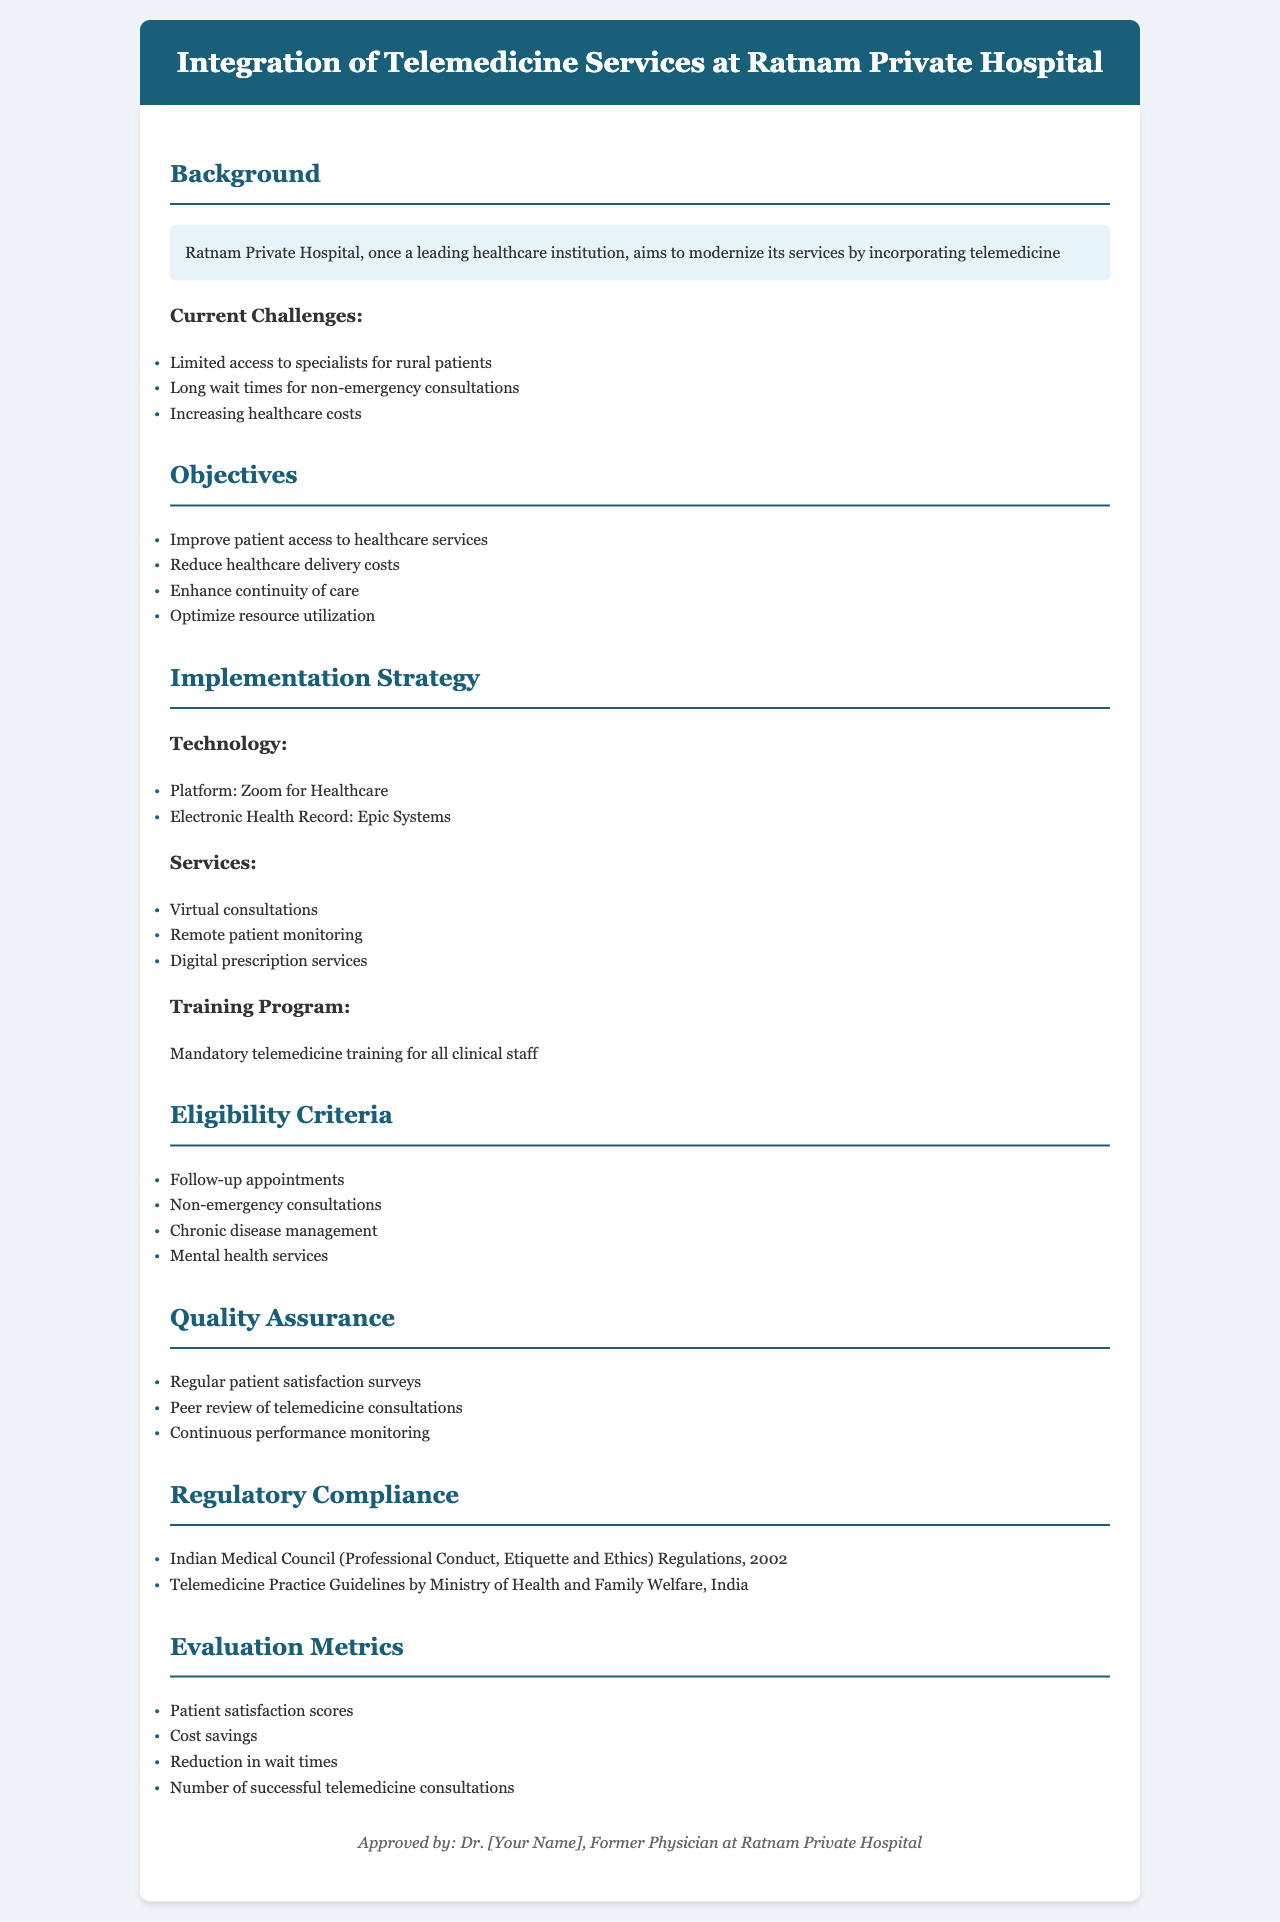What is the title of the policy document? The title is stated at the top of the document in the header section, which outlines the main focus of the policy.
Answer: Integration of Telemedicine Services at Ratnam Private Hospital What is the primary platform for virtual consultations? The document specifies the technology choice for virtual consultations, indicating the platform used.
Answer: Zoom for Healthcare List one current challenge faced by Ratnam Private Hospital. The document mentions several challenges in the background section, highlighting difficulties that need to be addressed.
Answer: Limited access to specialists for rural patients What is one objective of integrating telemedicine services? The objectives are outlined in a section that presents the goals of the policy clearly and concisely.
Answer: Improve patient access to healthcare services What type of training is mandatory for clinical staff? The implementation strategy highlights the necessity of training for effective use of telemedicine.
Answer: Telemedicine training Which regulatory guideline is mentioned for compliance? The document specifies the regulations that the hospital must adhere to regarding telemedicine, indicating necessary legal guidelines.
Answer: Telemedicine Practice Guidelines by Ministry of Health and Family Welfare, India How will patient satisfaction be monitored? The quality assurance section discusses the methods for evaluating the effectiveness of telemedicine services focusing on patient feedback.
Answer: Regular patient satisfaction surveys What is listed as an evaluation metric for the telemedicine services? The metrics for assessing the performance of telemedicine services are presented in the evaluation section, providing criteria for success.
Answer: Patient satisfaction scores 